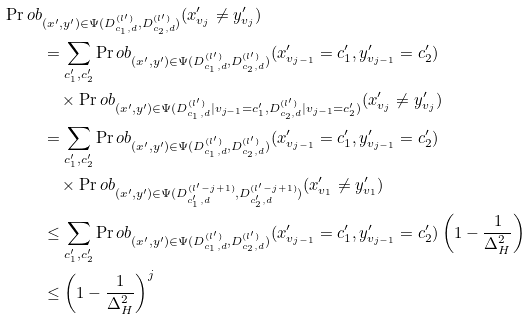Convert formula to latex. <formula><loc_0><loc_0><loc_500><loc_500>\Pr o b & _ { ( x ^ { \prime } , y ^ { \prime } ) \in \Psi ( D _ { c _ { 1 } , d } ^ { ( l ^ { \prime } ) } , D _ { c _ { 2 } , d } ^ { ( l ^ { \prime } ) } ) } ( x _ { v _ { j } } ^ { \prime } \neq y _ { v _ { j } } ^ { \prime } ) \\ & = \sum _ { c _ { 1 } ^ { \prime } , c _ { 2 } ^ { \prime } } \Pr o b _ { ( x ^ { \prime } , y ^ { \prime } ) \in \Psi ( D _ { c _ { 1 } , d } ^ { ( l ^ { \prime } ) } , D _ { c _ { 2 } , d } ^ { ( l ^ { \prime } ) } ) } ( x _ { v _ { j - 1 } } ^ { \prime } = c _ { 1 } ^ { \prime } , y _ { v _ { j - 1 } } ^ { \prime } = c _ { 2 } ^ { \prime } ) \\ & \quad \times \Pr o b _ { ( x ^ { \prime } , y ^ { \prime } ) \in \Psi ( D _ { c _ { 1 } , d } ^ { ( l ^ { \prime } ) } | v _ { j - 1 } = c _ { 1 } ^ { \prime } , D _ { c _ { 2 } , d } ^ { ( l ^ { \prime } ) } | v _ { j - 1 } = c _ { 2 } ^ { \prime } ) } ( x _ { v _ { j } } ^ { \prime } \neq y _ { v _ { j } } ^ { \prime } ) \\ & = \sum _ { c _ { 1 } ^ { \prime } , c _ { 2 } ^ { \prime } } \Pr o b _ { ( x ^ { \prime } , y ^ { \prime } ) \in \Psi ( D _ { c _ { 1 } , d } ^ { ( l ^ { \prime } ) } , D _ { c _ { 2 } , d } ^ { ( l ^ { \prime } ) } ) } ( x _ { v _ { j - 1 } } ^ { \prime } = c _ { 1 } ^ { \prime } , y _ { v _ { j - 1 } } ^ { \prime } = c _ { 2 } ^ { \prime } ) \\ & \quad \times \Pr o b _ { ( x ^ { \prime } , y ^ { \prime } ) \in \Psi ( D _ { c _ { 1 } ^ { \prime } , d } ^ { ( l ^ { \prime } - j + 1 ) } , D _ { c _ { 2 } ^ { \prime } , d } ^ { ( l ^ { \prime } - j + 1 ) } ) } ( x _ { v _ { 1 } } ^ { \prime } \neq y _ { v _ { 1 } } ^ { \prime } ) \\ & \leq \sum _ { c _ { 1 } ^ { \prime } , c _ { 2 } ^ { \prime } } \Pr o b _ { ( x ^ { \prime } , y ^ { \prime } ) \in \Psi ( D _ { c _ { 1 } , d } ^ { ( l ^ { \prime } ) } , D _ { c _ { 2 } , d } ^ { ( l ^ { \prime } ) } ) } ( x _ { v _ { j - 1 } } ^ { \prime } = c _ { 1 } ^ { \prime } , y _ { v _ { j - 1 } } ^ { \prime } = c _ { 2 } ^ { \prime } ) \left ( 1 - \frac { 1 } { \Delta _ { H } ^ { 2 } } \right ) \\ & \leq \left ( 1 - \frac { 1 } { \Delta _ { H } ^ { 2 } } \right ) ^ { j }</formula> 